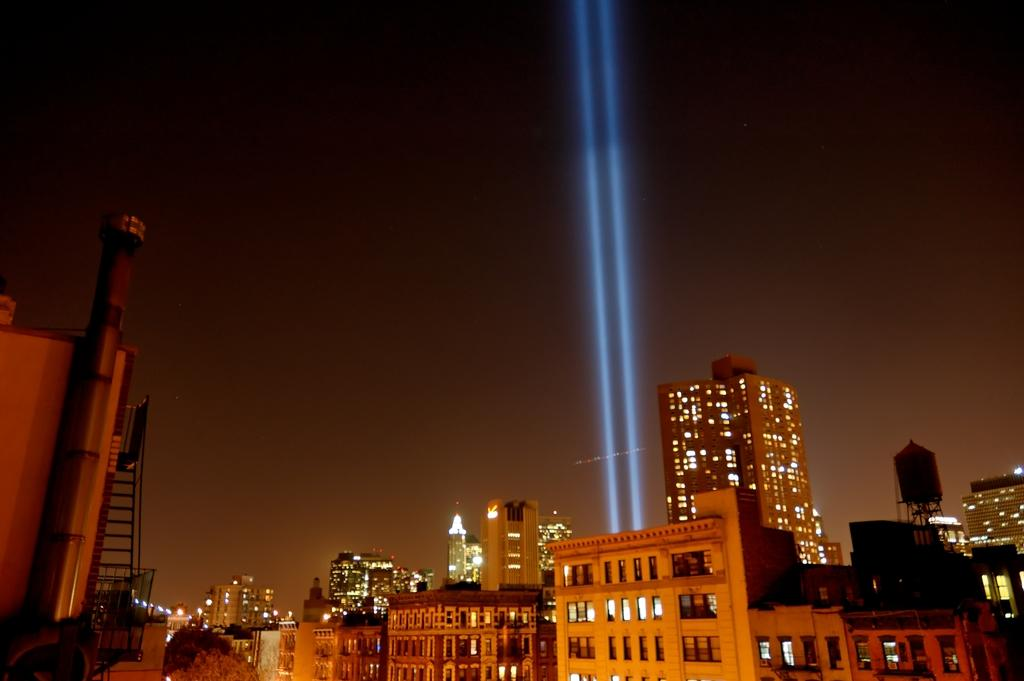What type of structures are located at the bottom of the image? There are buildings at the bottom of the image. What can be seen in the middle of the image? There is a light focus in the middle of the image. What is visible in the background of the image? The sky is visible in the background of the image. Where is the mine located in the image? There is no mine present in the image. What type of seed can be seen growing in the image? There are no seeds visible in the image. 